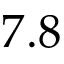Convert formula to latex. <formula><loc_0><loc_0><loc_500><loc_500>7 . 8</formula> 